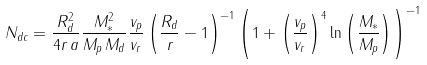Convert formula to latex. <formula><loc_0><loc_0><loc_500><loc_500>N _ { d c } = \frac { R _ { d } ^ { 2 } } { 4 r \, a } \frac { M _ { * } ^ { 2 } } { M _ { p } \, M _ { d } } \frac { v _ { p } } { v _ { r } } \left ( \frac { R _ { d } } { r } - 1 \right ) ^ { - 1 } \left ( 1 + \left ( \frac { v _ { p } } { v _ { r } } \right ) ^ { 4 } \ln \left ( \frac { M _ { * } } { M _ { p } } \right ) \right ) ^ { - 1 }</formula> 